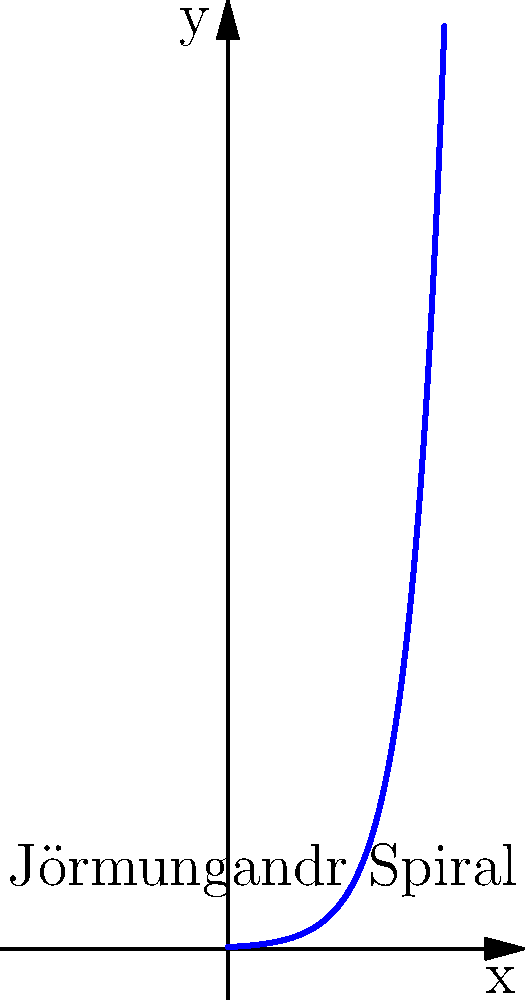As a tattoo artist specializing in Norse mythology designs, you're creating a spiral tattoo of Jörmungandr, the World Serpent. The spiral follows the equation $r = ae^{b\theta}$, where $a = 0.1$ and $b = 0.5$. If the spiral makes two complete revolutions, what is the total length of the curve to the nearest tenth of a unit? To find the length of the spiral curve, we'll use the arc length formula for polar curves:

1) The formula is: $L = \int_0^{\theta} \sqrt{r^2 + (\frac{dr}{d\theta})^2} d\theta$

2) For our spiral, $r = ae^{b\theta}$, so $\frac{dr}{d\theta} = abe^{b\theta}$

3) Substituting into the formula:
   $L = \int_0^{\theta} \sqrt{(ae^{b\theta})^2 + (abe^{b\theta})^2} d\theta$

4) Simplifying:
   $L = \int_0^{\theta} \sqrt{a^2e^{2b\theta} + a^2b^2e^{2b\theta}} d\theta$
   $L = \int_0^{\theta} ae^{b\theta}\sqrt{1 + b^2} d\theta$

5) Two complete revolutions means $\theta = 4\pi$. Evaluating the integral:
   $L = a\sqrt{1 + b^2} [\frac{1}{b}e^{b\theta}]_0^{4\pi}$
   $L = \frac{a\sqrt{1 + b^2}}{b} (e^{4\pi b} - 1)$

6) Plugging in $a = 0.1$ and $b = 0.5$:
   $L = \frac{0.1\sqrt{1 + 0.5^2}}{0.5} (e^{2\pi} - 1)$

7) Calculating:
   $L \approx 13.7$ units

8) Rounding to the nearest tenth:
   $L \approx 13.7$ units
Answer: 13.7 units 